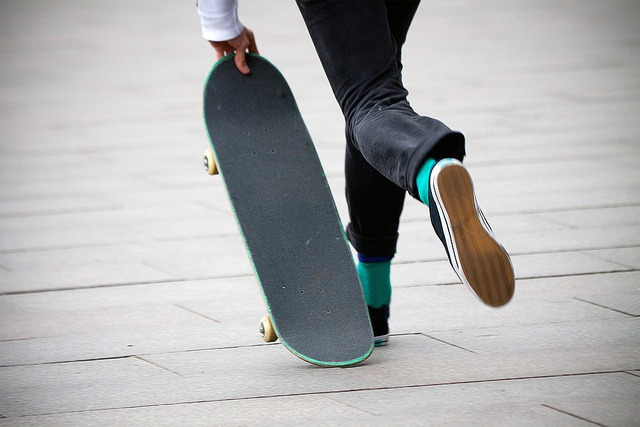Describe the objects in this image and their specific colors. I can see skateboard in gray, black, purple, and lightgray tones and people in gray, black, maroon, and lightgray tones in this image. 